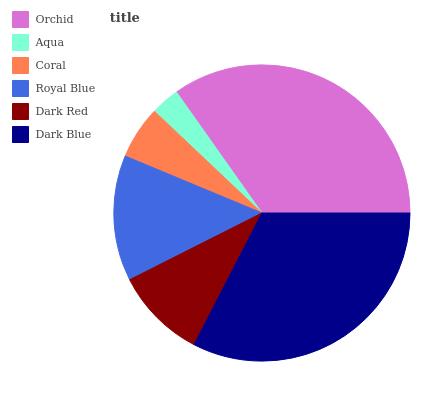Is Aqua the minimum?
Answer yes or no. Yes. Is Orchid the maximum?
Answer yes or no. Yes. Is Coral the minimum?
Answer yes or no. No. Is Coral the maximum?
Answer yes or no. No. Is Coral greater than Aqua?
Answer yes or no. Yes. Is Aqua less than Coral?
Answer yes or no. Yes. Is Aqua greater than Coral?
Answer yes or no. No. Is Coral less than Aqua?
Answer yes or no. No. Is Royal Blue the high median?
Answer yes or no. Yes. Is Dark Red the low median?
Answer yes or no. Yes. Is Orchid the high median?
Answer yes or no. No. Is Aqua the low median?
Answer yes or no. No. 